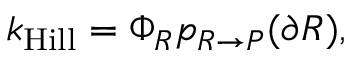Convert formula to latex. <formula><loc_0><loc_0><loc_500><loc_500>k _ { H i l l } = \Phi _ { R } p _ { R \rightarrow P } ( \partial R ) ,</formula> 